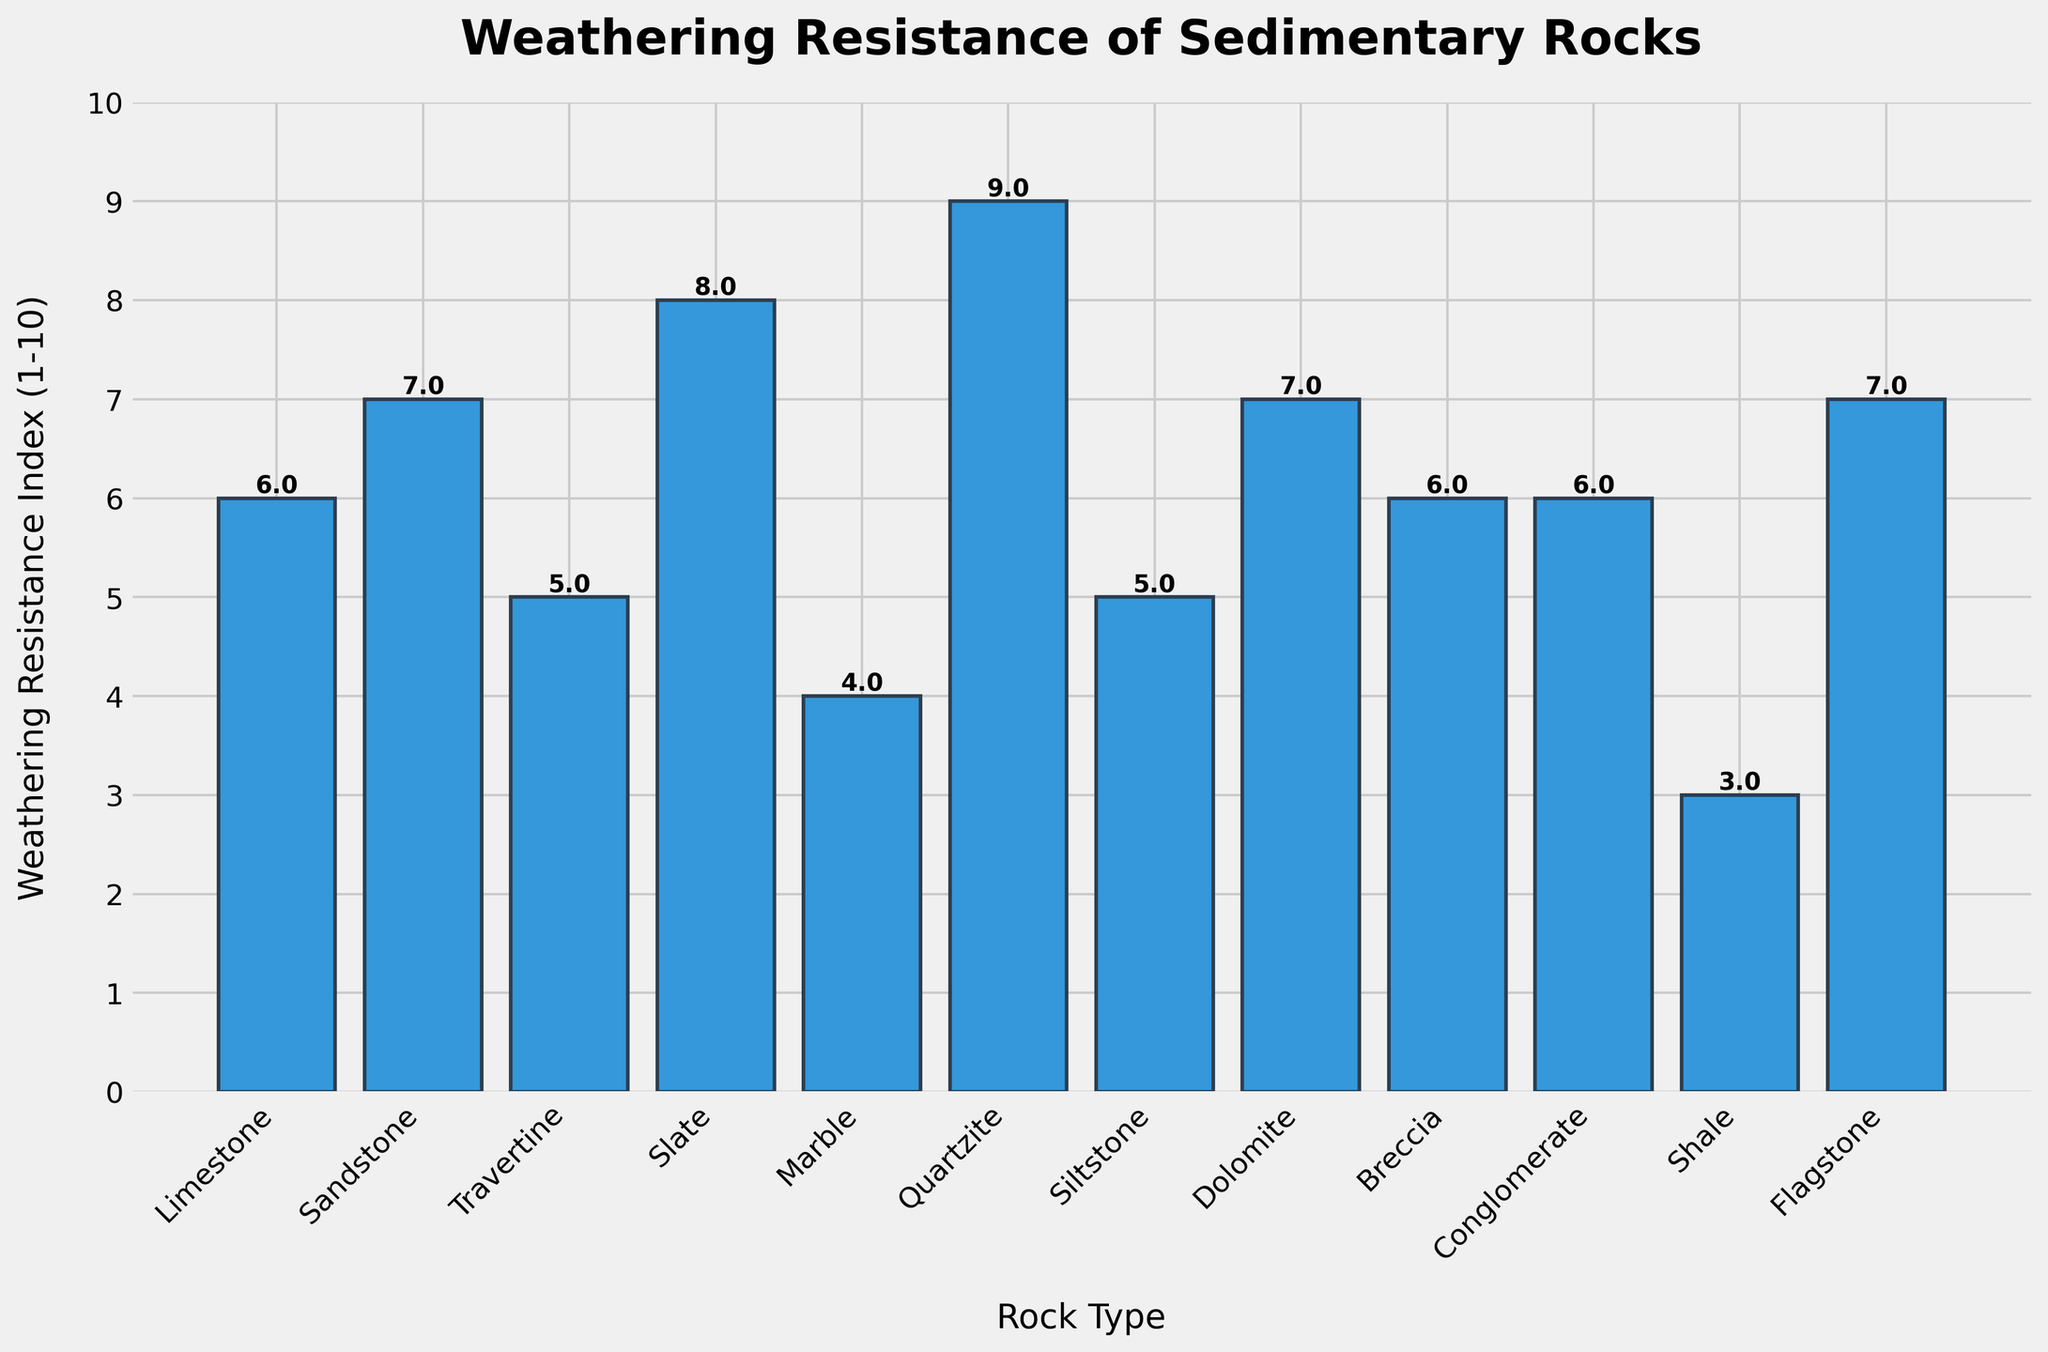What's the weathering resistance index of the rock type Slate? Looking at the bar corresponding to Slate, its height represents the weathering resistance index.
Answer: 8 Which rock type has the highest weathering resistance index? The tallest bar corresponds to Quartzite.
Answer: Quartzite Which rock types have the lowest and second lowest weathering resistance index? The shortest bars correspond to Shale and Marble, in order.
Answer: Shale and Marble What is the difference in weathering resistance index between Sandstone and Travertine? The bar for Sandstone has an index of 7, while Travertine has an index of 5. The difference is 7 - 5 = 2.
Answer: 2 How many rock types have a weathering resistance index greater than 6? Count the bars with heights greater than 6: Sandstone, Slate, Quartzite, Dolomite, and Flagstone. There are 5 such rock types.
Answer: 5 Which rock types have a weathering resistance index equal to 6? The bars for Limestone, Breccia, and Conglomerate have a height that represents an index of 6.
Answer: Limestone, Breccia, and Conglomerate What's the average weathering resistance index of all the rock types shown? Sum up all the index values: 6 + 7 + 5 + 8 + 4 + 9 + 5 + 7 + 6 + 6 + 3 + 7 = 73. There are 12 rock types. The average is 73 / 12 ≈ 6.08.
Answer: 6.08 Which rock types have the same weathering resistance index? Limestone, Breccia, and Conglomerate all have an index of 6. Sandstone, Dolomite, and Flagstone all have an index of 7. Travertine and Siltstone both have an index of 5.
Answer: Limestone, Breccia, Conglomerate; Sandstone, Dolomite, Flagstone; Travertine, Siltstone How many rock types have a weathering resistance index less than or equal to 5? Count the bars with heights of 5 or less: Travertine, Marble, Siltstone, and Shale. There are 4 such rock types.
Answer: 4 